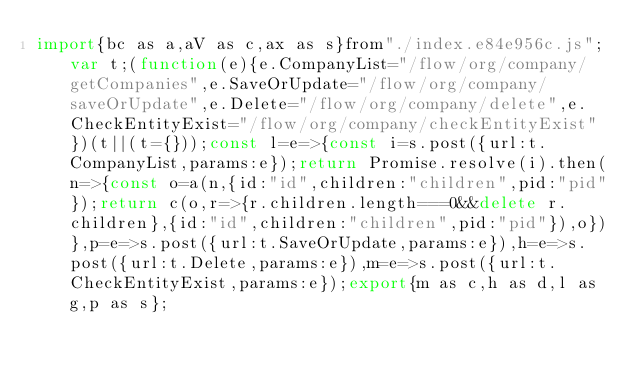Convert code to text. <code><loc_0><loc_0><loc_500><loc_500><_JavaScript_>import{bc as a,aV as c,ax as s}from"./index.e84e956c.js";var t;(function(e){e.CompanyList="/flow/org/company/getCompanies",e.SaveOrUpdate="/flow/org/company/saveOrUpdate",e.Delete="/flow/org/company/delete",e.CheckEntityExist="/flow/org/company/checkEntityExist"})(t||(t={}));const l=e=>{const i=s.post({url:t.CompanyList,params:e});return Promise.resolve(i).then(n=>{const o=a(n,{id:"id",children:"children",pid:"pid"});return c(o,r=>{r.children.length===0&&delete r.children},{id:"id",children:"children",pid:"pid"}),o})},p=e=>s.post({url:t.SaveOrUpdate,params:e}),h=e=>s.post({url:t.Delete,params:e}),m=e=>s.post({url:t.CheckEntityExist,params:e});export{m as c,h as d,l as g,p as s};
</code> 